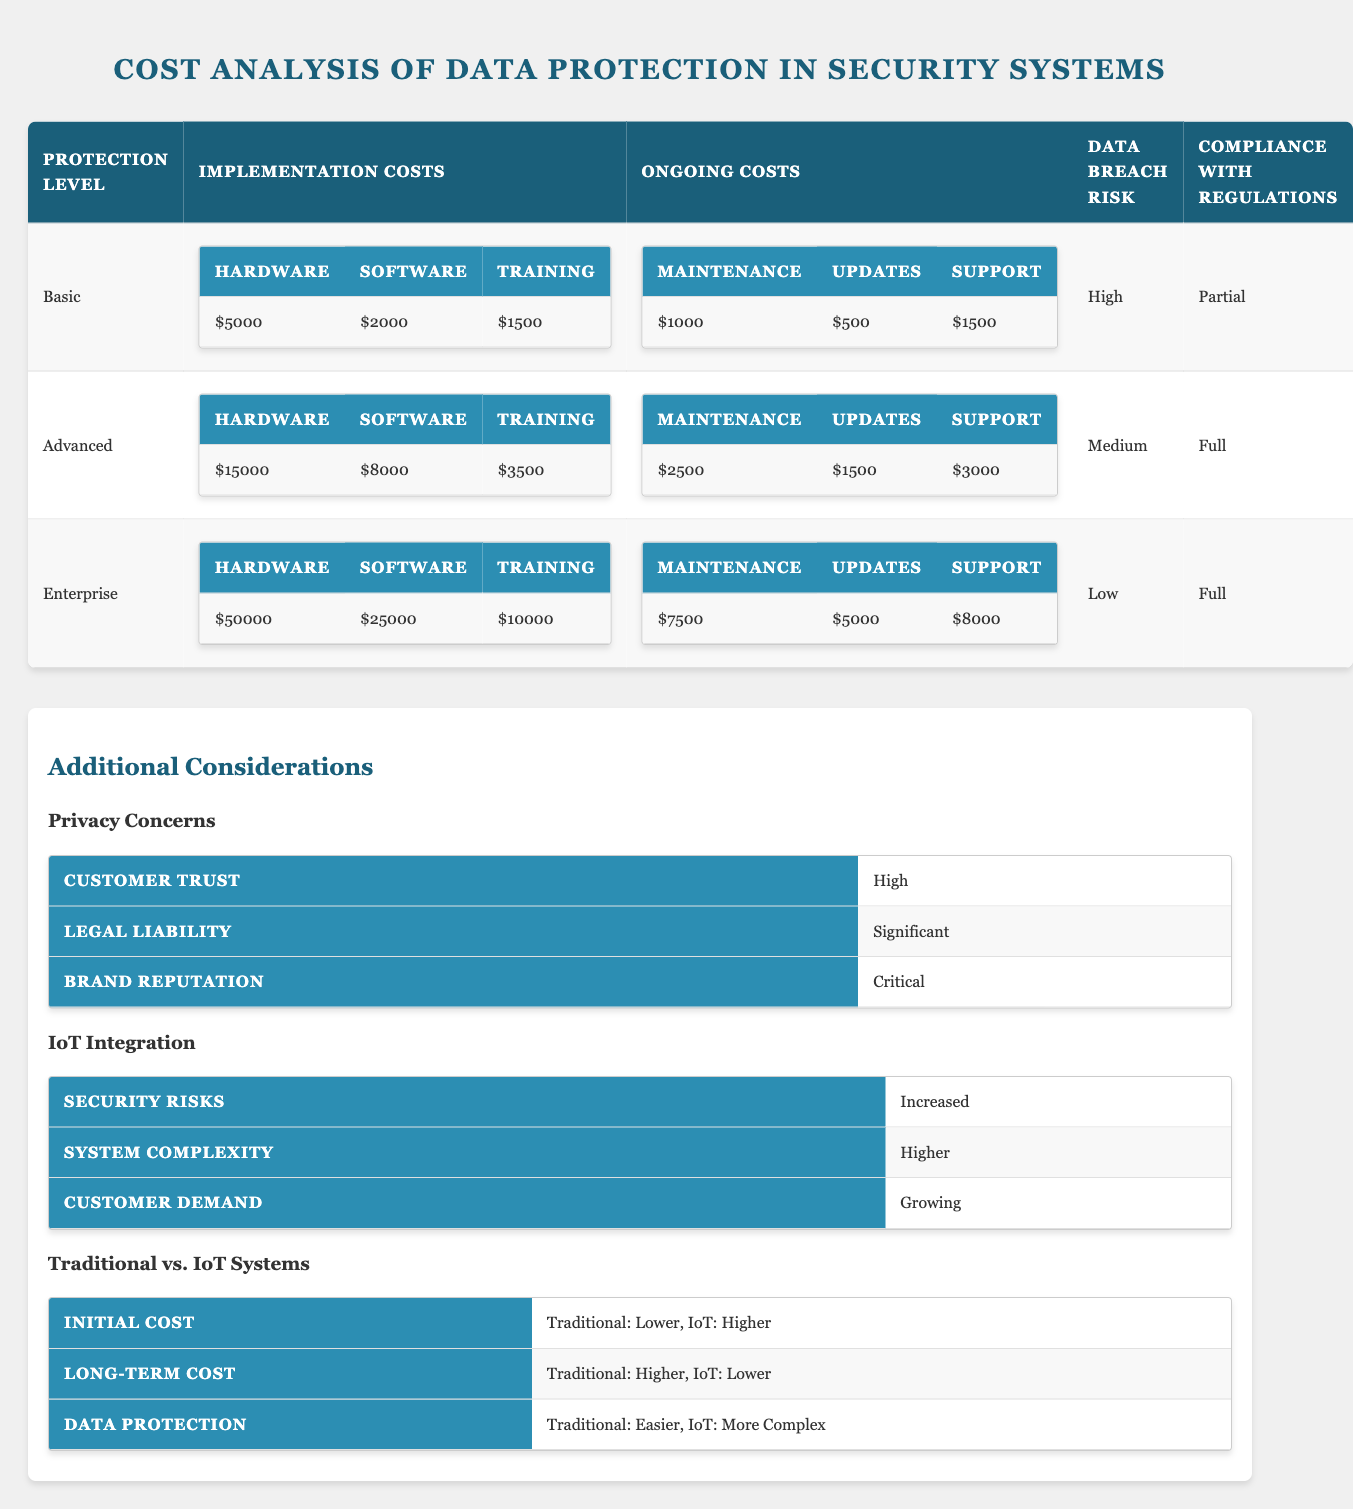What is the total implementation cost for the Advanced protection level? For Advanced protection level, the Implementation Costs consist of: Hardware ($15,000) + Software ($8,000) + Training ($3,500). Summing these values gives us $15,000 + $8,000 + $3,500 = $26,500.
Answer: $26,500 What is the ongoing maintenance cost for the Basic protection level? The ongoing maintenance cost for the Basic protection level is listed as $1,000.
Answer: $1,000 Which protection level has the lowest data breach risk? The Enterprise protection level has the data breach risk labeled as "Low".
Answer: Enterprise What is the total sum of implementation costs across all protection levels? The total implementation costs are: Basic ($5,000 + $2,000 + $1,500), Advanced ($15,000 + $8,000 + $3,500), and Enterprise ($50,000 + $25,000 + $10,000). Calculating these: Basic = $8,500, Advanced = $26,500, Enterprise = $85,000. Adding these gives $8,500 + $26,500 + $85,000 = $120,000.
Answer: $120,000 Does the Basic protection level achieve full compliance with regulations? The Basic protection level is marked as having "Partial" compliance with regulations, so it does not achieve full compliance.
Answer: No Which protection level incurs the highest ongoing support costs? The ongoing support costs for each protection level are: Basic ($1,500), Advanced ($3,000), and Enterprise ($8,000). The highest ongoing support cost is for the Enterprise protection level at $8,000.
Answer: Enterprise What factor might have a critical impact on brand reputation? The additional consideration for Privacy Concerns indicates that the impact on Brand Reputation is labeled as "Critical".
Answer: Privacy Concerns If we compare IoT integration with traditional systems, which is easier for data protection? The comparison states that Traditional systems are easier for data protection compared to IoT systems, which are described as more complex.
Answer: Traditional systems How much lower is the hardware cost for the Basic level compared to the Enterprise level? The hardware costs are $5,000 for Basic and $50,000 for Enterprise. The difference is $50,000 - $5,000 = $45,000.
Answer: $45,000 Which protection level offers full compliance with regulations? Both the Advanced and Enterprise protection levels achieve "Full" compliance with regulations.
Answer: Advanced and Enterprise 